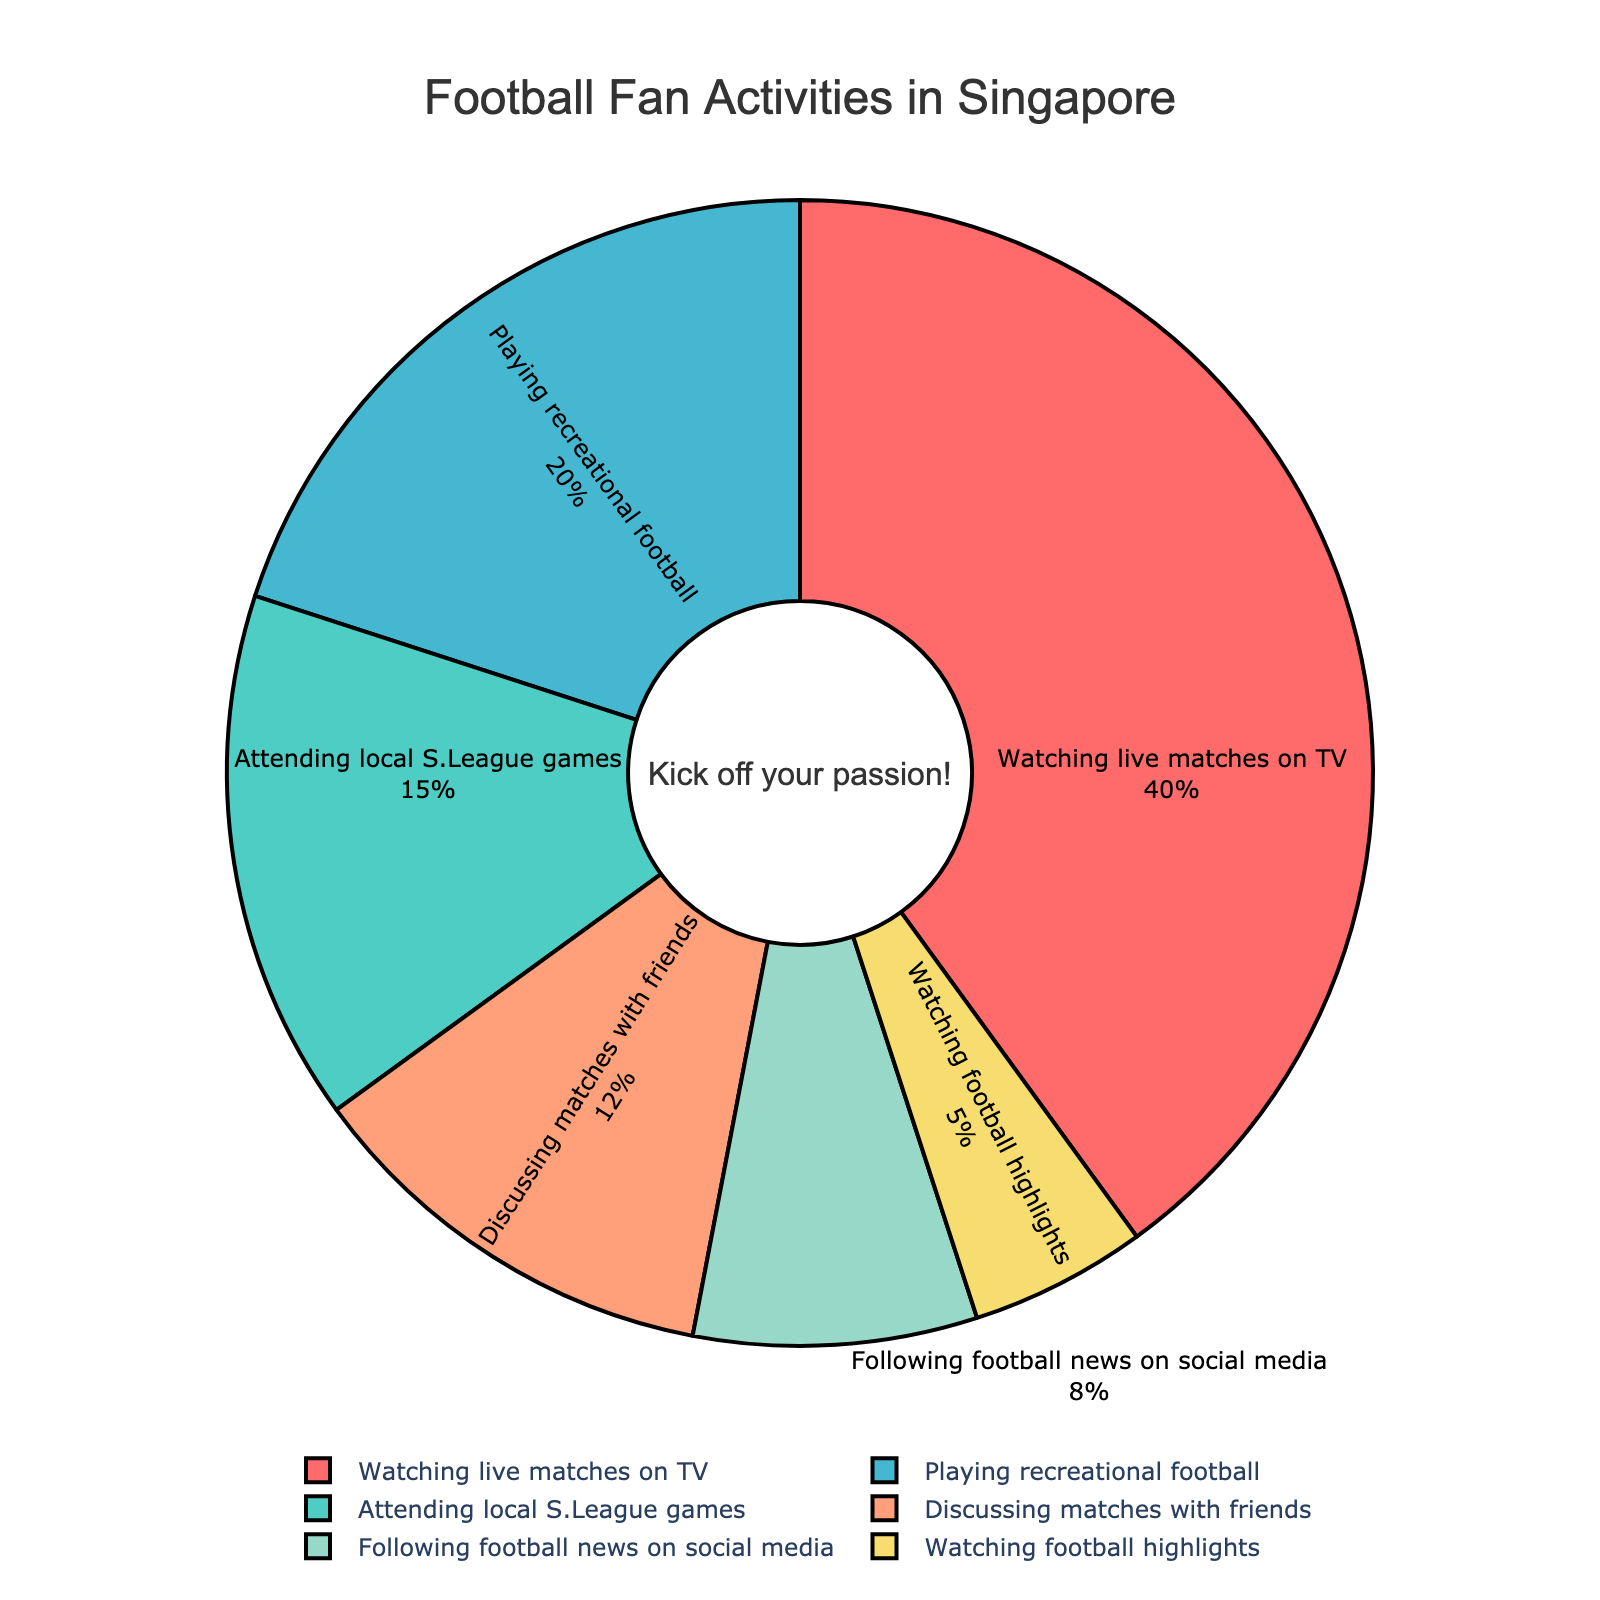What activity takes up the most time among Singaporean football fans? The largest section in the pie chart is labeled "Watching live matches on TV" which shows 40%, indicating that this activity takes up the most time.
Answer: Watching live matches on TV What percentage of time do fans spend on playing recreational football and discussing matches with friends combined? By adding the percentages for "Playing recreational football" (20%) and "Discussing matches with friends" (12%), we get 20% + 12% = 32%.
Answer: 32% Which activity takes up less time: watching football highlights or attending local S.League games? By comparing their respective percentages, "Watching football highlights" (5%) is less than "Attending local S.League games" (15%).
Answer: Watching football highlights What is the approximate difference in percentage between the time spent playing recreational football and following football news on social media? Subtract the percentage for "Following football news on social media" (8%) from "Playing recreational football" (20%), which is 20% - 8% = 12%.
Answer: 12% What activities occupy a smaller proportion of time compared to "Attending local S.League games"? "Attending local S.League games" is 15%. Activities with lesser percentages are "Discussing matches with friends" (12%), "Following football news on social media" (8%), and "Watching football highlights" (5%).
Answer: Discussing matches with friends, Following football news on social media, Watching football highlights How much more time do fans spend watching live matches on TV than watching football highlights? The difference in percentages between "Watching live matches on TV" (40%) and "Watching football highlights" (5%) is 40% - 5% = 35%.
Answer: 35% If the time spent on "Following football news on social media" is doubled, how much will it be? Doubling the percentage for "Following football news on social media" (8%) gives 8% * 2 = 16%.
Answer: 16% Is the sum of the time spent on "Watching football highlights" and "Following football news on social media" greater than the time spent "Playing recreational football"? Adding the percentages for "Watching football highlights" (5%) and "Following football news on social media" (8%) gives 5% + 8% = 13%, which is less than "Playing recreational football" (20%).
Answer: No What color represents the activity with the least time allocation? The smallest section of the pie chart is for "Watching football highlights" (5%), which is colored yellow in the provided figure.
Answer: Yellow How does the time spent "Discussing matches with friends" compare to time spent "Playing recreational football"? "Discussing matches with friends" (12%) is less than "Playing recreational football" (20%).
Answer: Less 